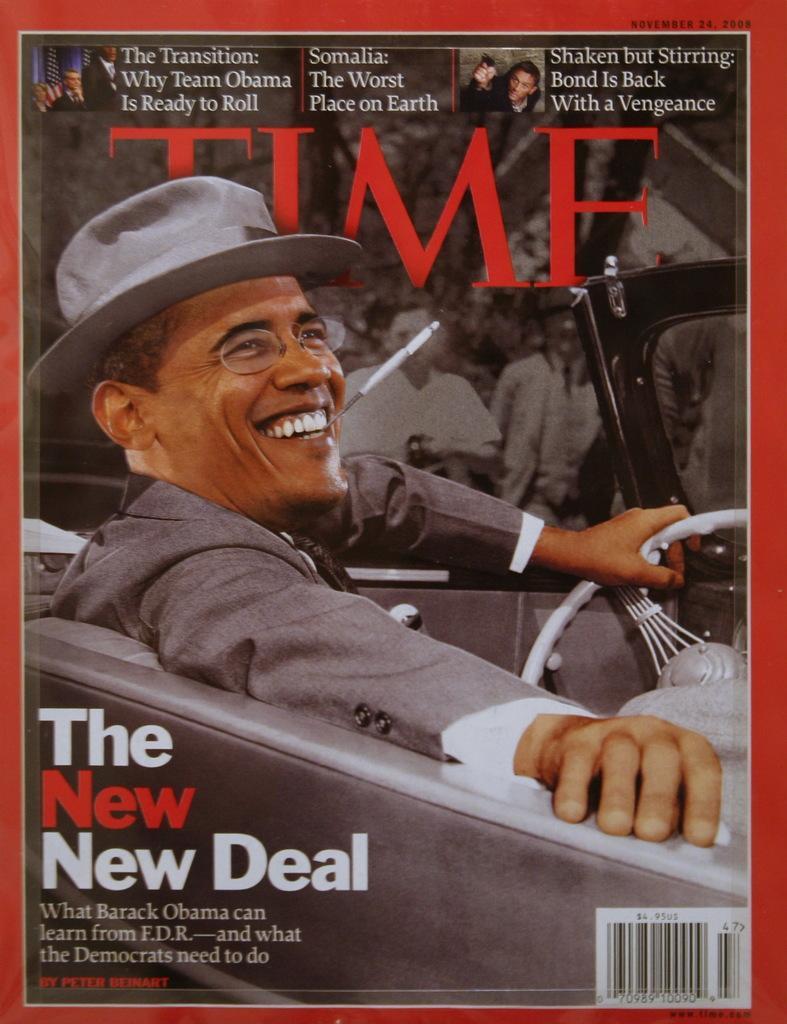Describe this image in one or two sentences. In this image there is a poster. In the center of the image there is a person sitting in a car. 